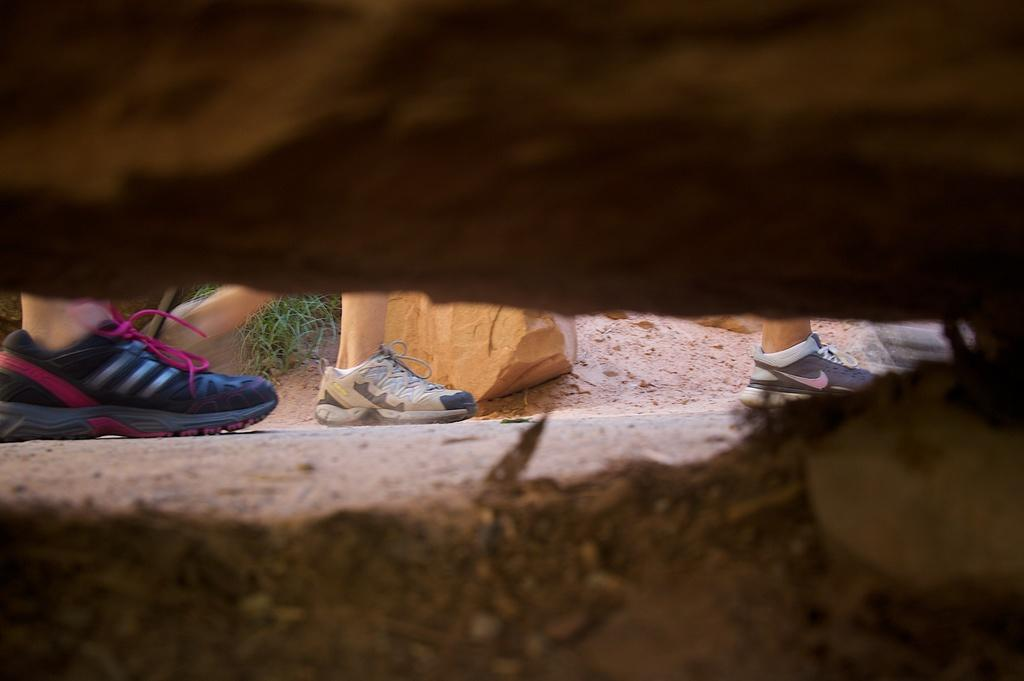What body parts are visible in the image? There are human legs visible in the image. What objects can be seen on the ground in the image? There is a rock and a plant on the ground in the image. What is the opinion of the cat in the image? There is no cat present in the image, so it is not possible to determine its opinion. 